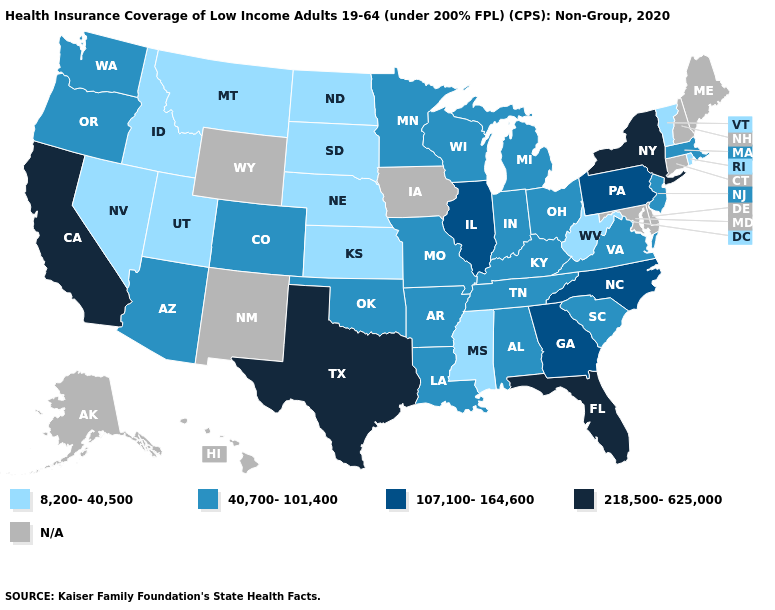Among the states that border Mississippi , which have the highest value?
Keep it brief. Alabama, Arkansas, Louisiana, Tennessee. What is the value of Arkansas?
Keep it brief. 40,700-101,400. Name the states that have a value in the range 8,200-40,500?
Be succinct. Idaho, Kansas, Mississippi, Montana, Nebraska, Nevada, North Dakota, Rhode Island, South Dakota, Utah, Vermont, West Virginia. Does Georgia have the highest value in the USA?
Short answer required. No. Name the states that have a value in the range N/A?
Write a very short answer. Alaska, Connecticut, Delaware, Hawaii, Iowa, Maine, Maryland, New Hampshire, New Mexico, Wyoming. Name the states that have a value in the range N/A?
Write a very short answer. Alaska, Connecticut, Delaware, Hawaii, Iowa, Maine, Maryland, New Hampshire, New Mexico, Wyoming. Does Arizona have the lowest value in the West?
Quick response, please. No. What is the value of Washington?
Answer briefly. 40,700-101,400. Among the states that border Utah , does Idaho have the highest value?
Be succinct. No. Name the states that have a value in the range N/A?
Write a very short answer. Alaska, Connecticut, Delaware, Hawaii, Iowa, Maine, Maryland, New Hampshire, New Mexico, Wyoming. Does the first symbol in the legend represent the smallest category?
Give a very brief answer. Yes. Name the states that have a value in the range 218,500-625,000?
Short answer required. California, Florida, New York, Texas. What is the value of Minnesota?
Short answer required. 40,700-101,400. 